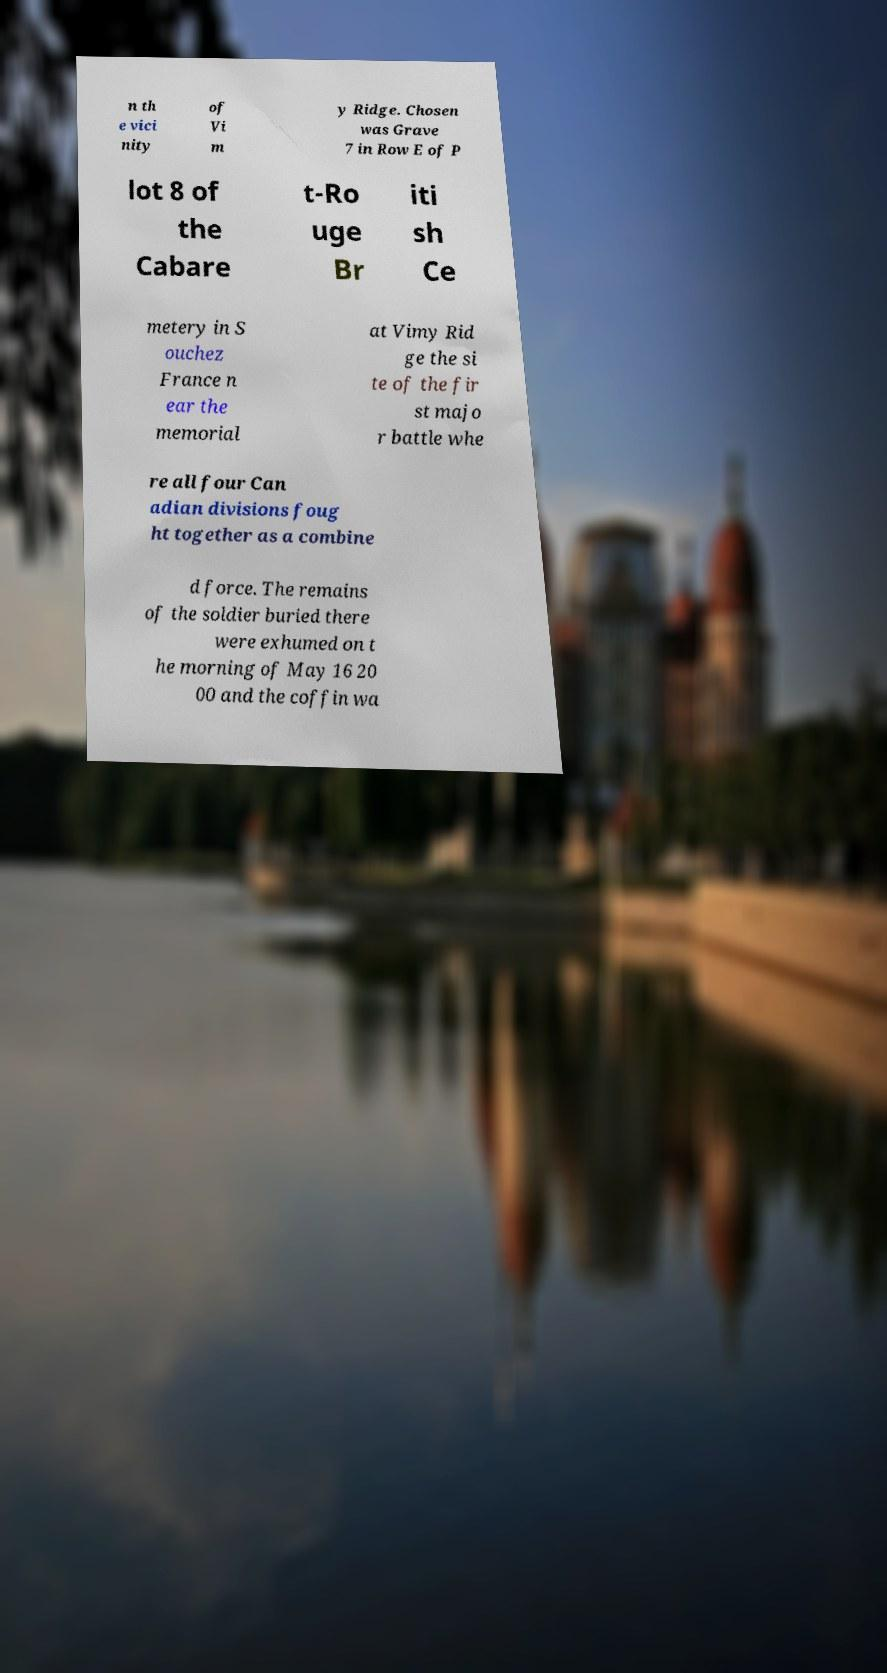Can you accurately transcribe the text from the provided image for me? n th e vici nity of Vi m y Ridge. Chosen was Grave 7 in Row E of P lot 8 of the Cabare t-Ro uge Br iti sh Ce metery in S ouchez France n ear the memorial at Vimy Rid ge the si te of the fir st majo r battle whe re all four Can adian divisions foug ht together as a combine d force. The remains of the soldier buried there were exhumed on t he morning of May 16 20 00 and the coffin wa 